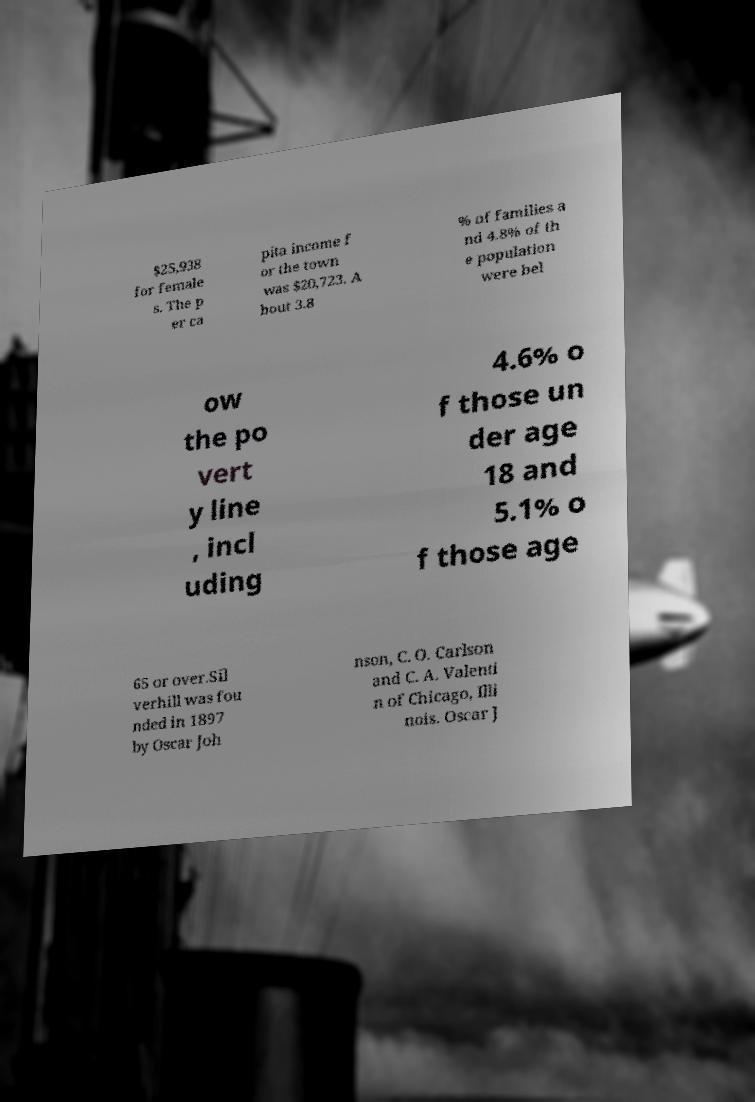I need the written content from this picture converted into text. Can you do that? $25,938 for female s. The p er ca pita income f or the town was $20,723. A bout 3.8 % of families a nd 4.8% of th e population were bel ow the po vert y line , incl uding 4.6% o f those un der age 18 and 5.1% o f those age 65 or over.Sil verhill was fou nded in 1897 by Oscar Joh nson, C. O. Carlson and C. A. Valenti n of Chicago, Illi nois. Oscar J 